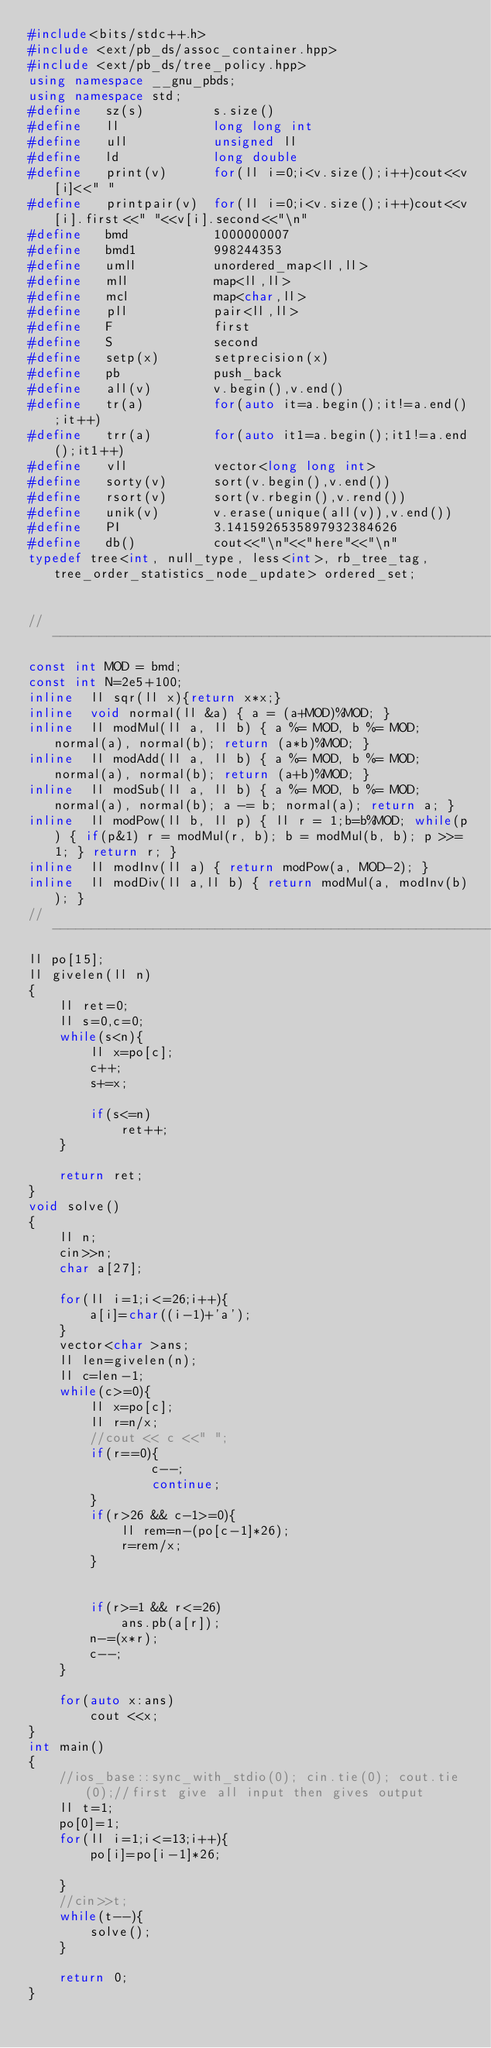<code> <loc_0><loc_0><loc_500><loc_500><_C++_>#include<bits/stdc++.h>
#include <ext/pb_ds/assoc_container.hpp>
#include <ext/pb_ds/tree_policy.hpp>
using namespace __gnu_pbds;
using namespace std;
#define   sz(s)         s.size()
#define   ll            long long int
#define   ull           unsigned ll
#define   ld            long double
#define   print(v)      for(ll i=0;i<v.size();i++)cout<<v[i]<<" "
#define   printpair(v)  for(ll i=0;i<v.size();i++)cout<<v[i].first<<" "<<v[i].second<<"\n"
#define   bmd           1000000007
#define   bmd1          998244353
#define   umll          unordered_map<ll,ll>
#define   mll           map<ll,ll>
#define   mcl           map<char,ll>
#define   pll           pair<ll,ll>
#define   F             first
#define   S             second
#define   setp(x)       setprecision(x)
#define   pb            push_back
#define   all(v)        v.begin(),v.end()
#define   tr(a)         for(auto it=a.begin();it!=a.end();it++)
#define   trr(a)        for(auto it1=a.begin();it1!=a.end();it1++)
#define   vll           vector<long long int>
#define   sorty(v)      sort(v.begin(),v.end())
#define   rsort(v)      sort(v.rbegin(),v.rend())
#define   unik(v)       v.erase(unique(all(v)),v.end())
#define   PI            3.1415926535897932384626
#define   db()          cout<<"\n"<<"here"<<"\n"
typedef tree<int, null_type, less<int>, rb_tree_tag, tree_order_statistics_node_update> ordered_set;


//---------------------------------------------------------------------------
const int MOD = bmd;
const int N=2e5+100;
inline  ll sqr(ll x){return x*x;}
inline  void normal(ll &a) { a = (a+MOD)%MOD; }
inline  ll modMul(ll a, ll b) { a %= MOD, b %= MOD; normal(a), normal(b); return (a*b)%MOD; }
inline  ll modAdd(ll a, ll b) { a %= MOD, b %= MOD; normal(a), normal(b); return (a+b)%MOD; }
inline  ll modSub(ll a, ll b) { a %= MOD, b %= MOD; normal(a), normal(b); a -= b; normal(a); return a; }
inline  ll modPow(ll b, ll p) { ll r = 1;b=b%MOD; while(p) { if(p&1) r = modMul(r, b); b = modMul(b, b); p >>= 1; } return r; }
inline  ll modInv(ll a) { return modPow(a, MOD-2); }
inline  ll modDiv(ll a,ll b) { return modMul(a, modInv(b)); }
//---------------------------------------------------------------------------
ll po[15];
ll givelen(ll n)
{
    ll ret=0;
    ll s=0,c=0;
    while(s<n){
        ll x=po[c];
        c++;
        s+=x;

        if(s<=n)
            ret++;
    }

    return ret;
}
void solve()
{
    ll n;
    cin>>n;
    char a[27];

    for(ll i=1;i<=26;i++){
        a[i]=char((i-1)+'a');
    }
    vector<char >ans;
    ll len=givelen(n);
    ll c=len-1;
    while(c>=0){
        ll x=po[c];
        ll r=n/x;
        //cout << c <<" ";
        if(r==0){
                c--;
                continue;
        }
        if(r>26 && c-1>=0){
            ll rem=n-(po[c-1]*26);
            r=rem/x;
        }


        if(r>=1 && r<=26)
            ans.pb(a[r]);
        n-=(x*r);
        c--;
    }

    for(auto x:ans)
        cout <<x;
}
int main()
{
    //ios_base::sync_with_stdio(0); cin.tie(0); cout.tie(0);//first give all input then gives output
    ll t=1;
    po[0]=1;
    for(ll i=1;i<=13;i++){
        po[i]=po[i-1]*26;

    }
    //cin>>t;
    while(t--){
        solve();
    }

    return 0;
}
</code> 